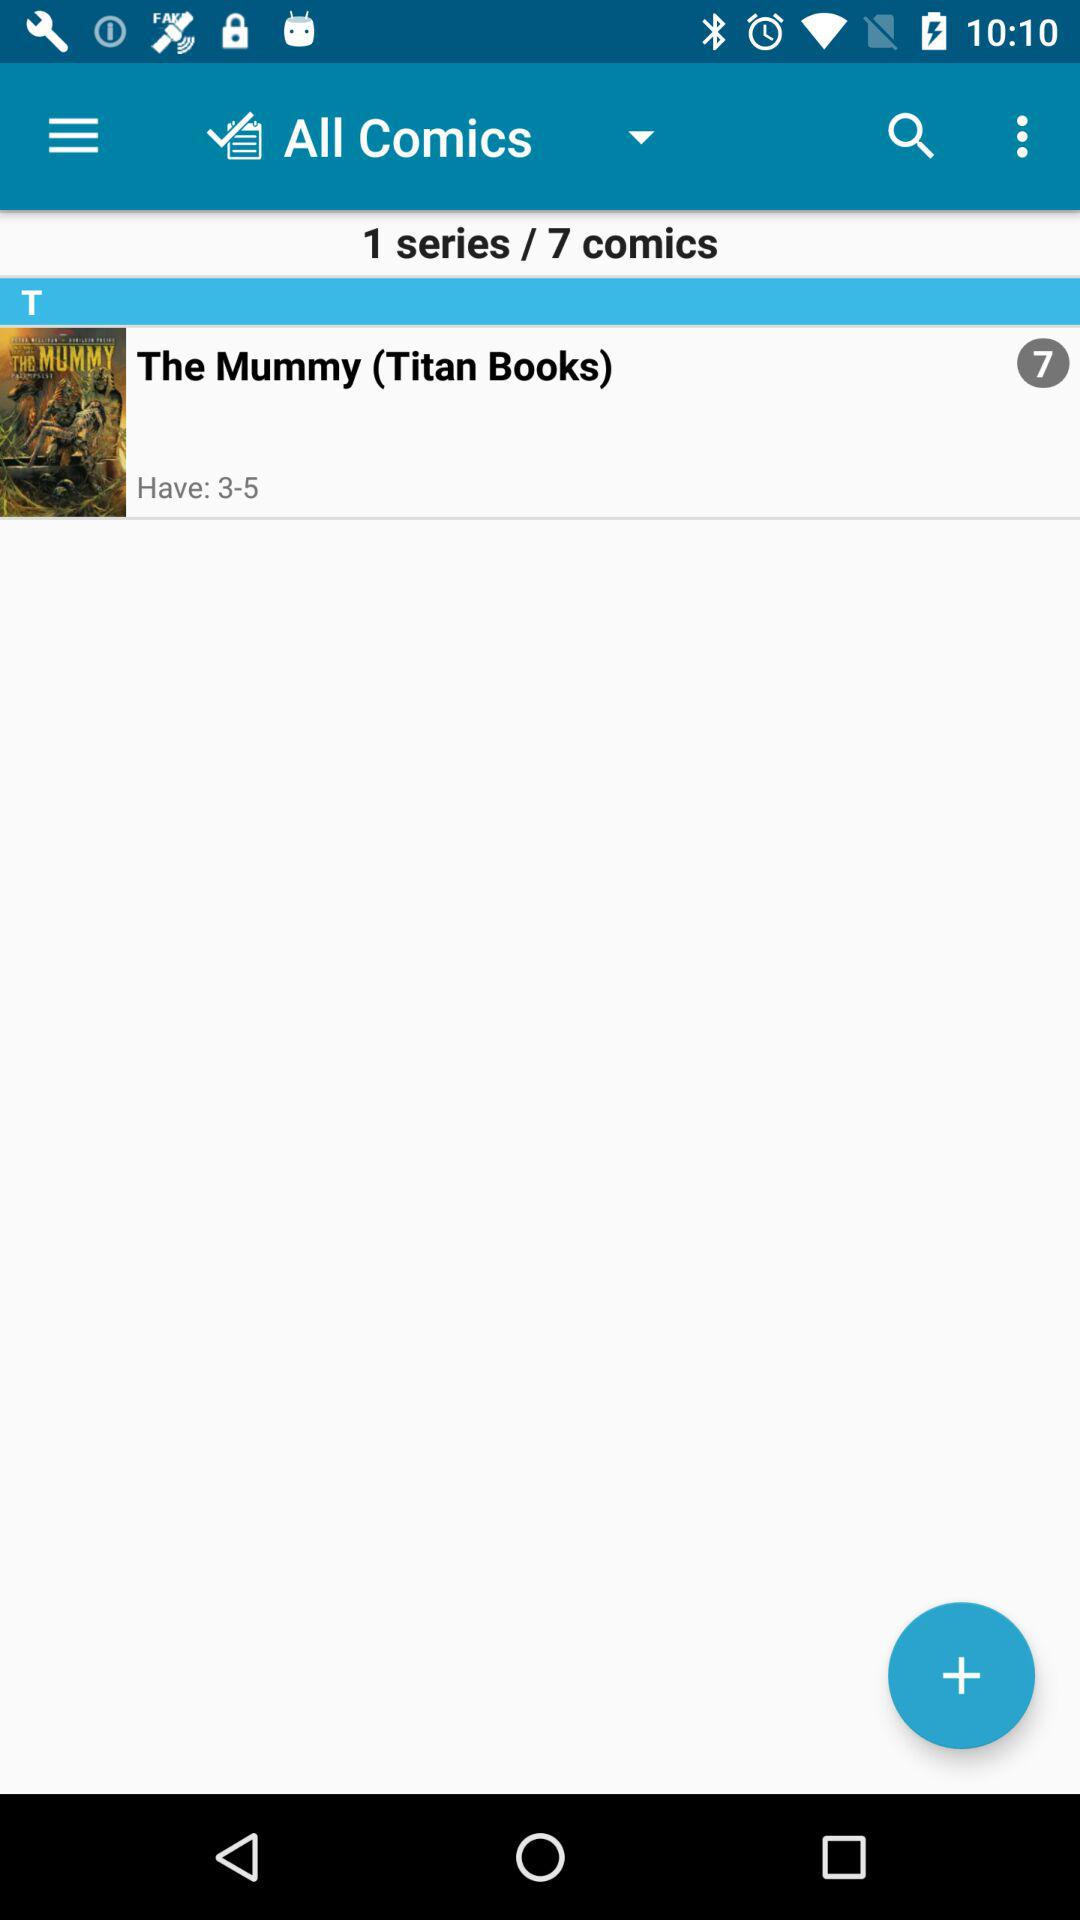What's the series number? The series number is 1. 